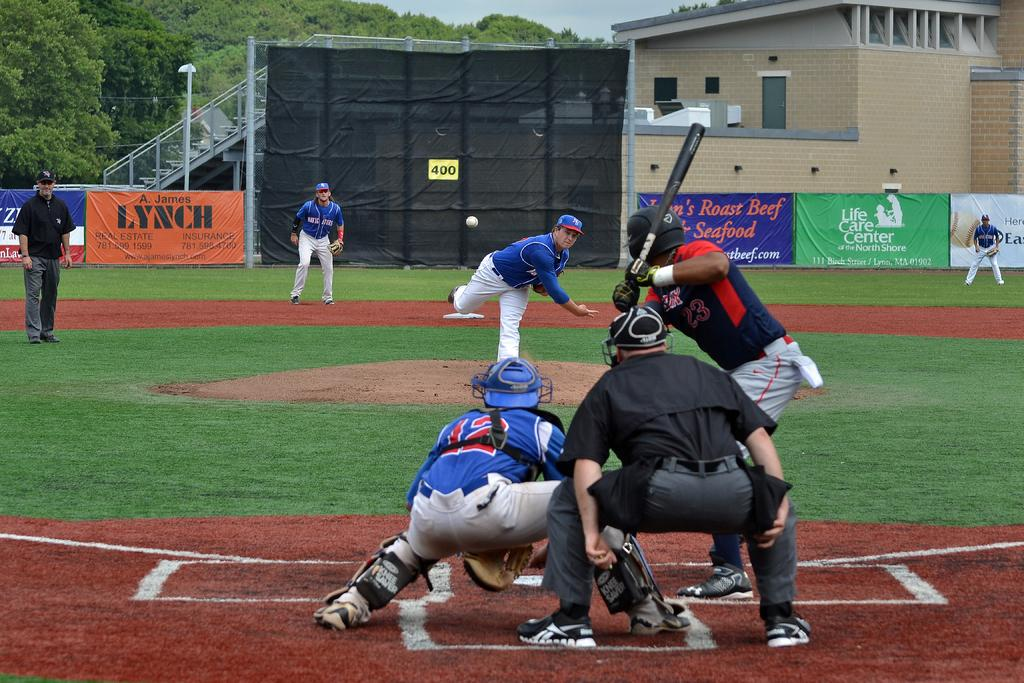<image>
Create a compact narrative representing the image presented. a catcher on a baseball field playing with the number 12 